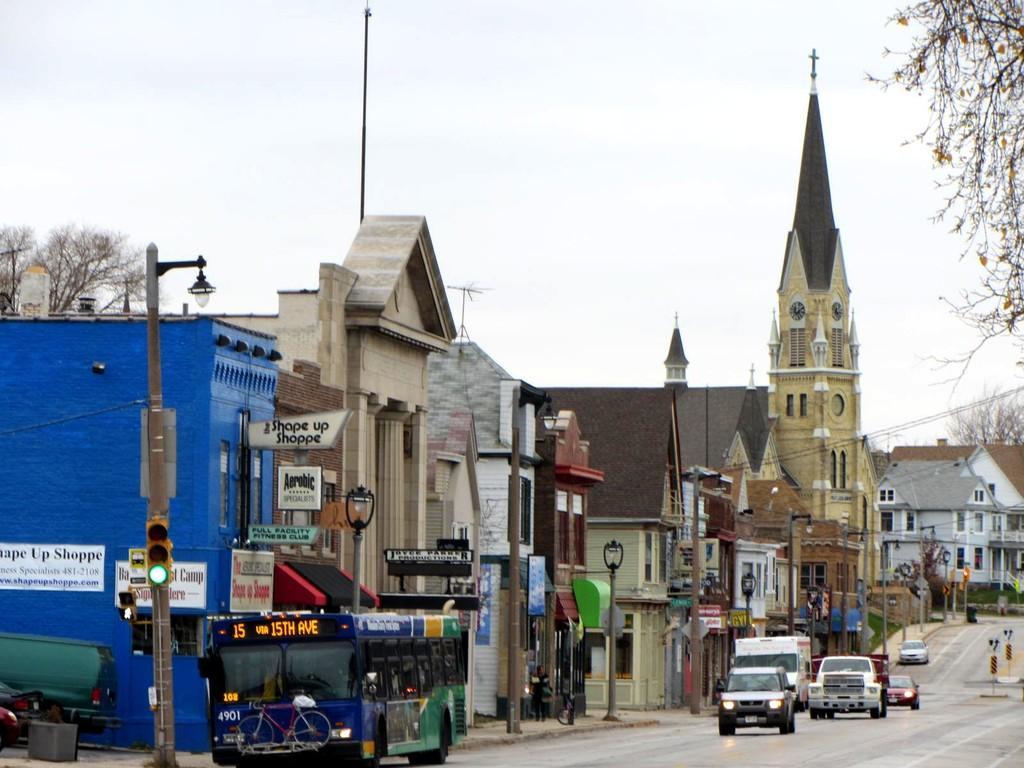Describe this image in one or two sentences. In this image we can see a group of buildings and a tower with a clock. We can also see some vehicles on the road, some street lamps, traffic signal, some trees, wires, sign boards with some text on it and the sky which looks cloudy. 